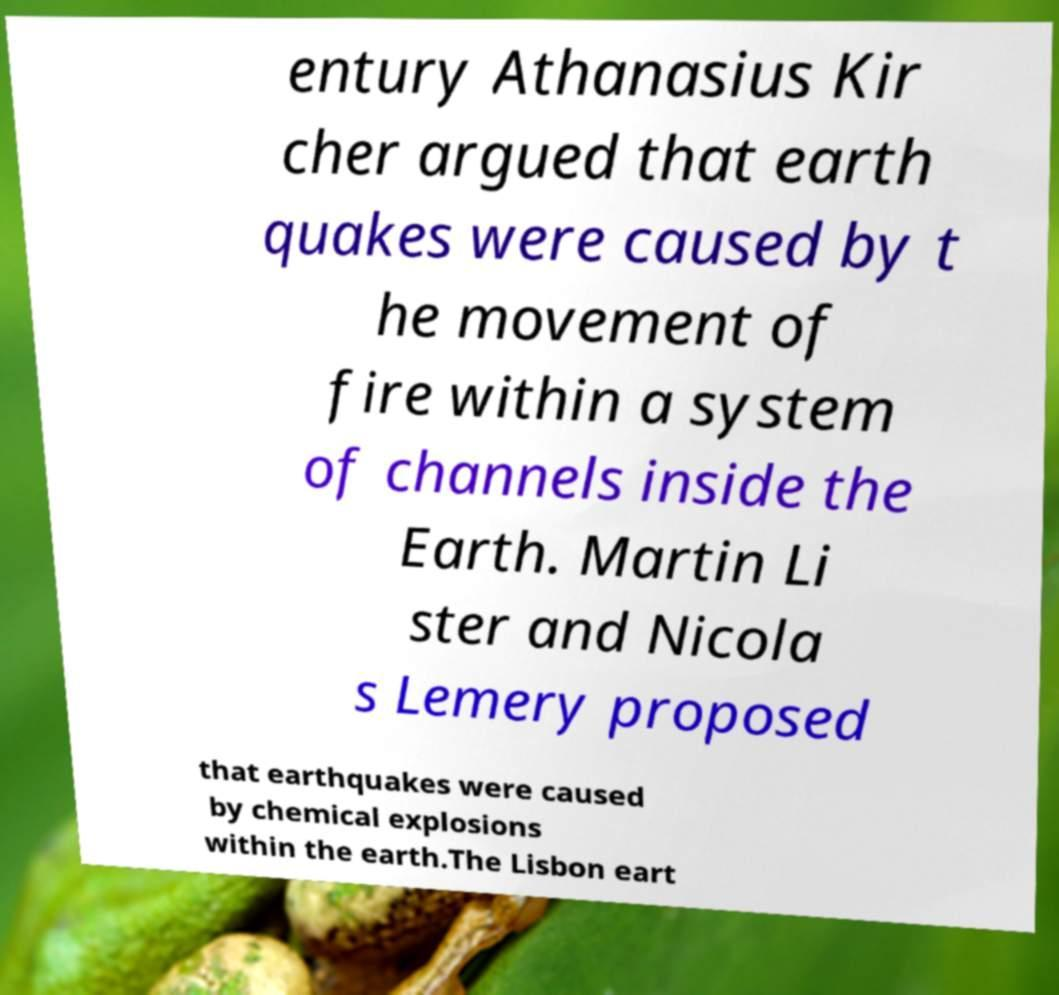What messages or text are displayed in this image? I need them in a readable, typed format. entury Athanasius Kir cher argued that earth quakes were caused by t he movement of fire within a system of channels inside the Earth. Martin Li ster and Nicola s Lemery proposed that earthquakes were caused by chemical explosions within the earth.The Lisbon eart 